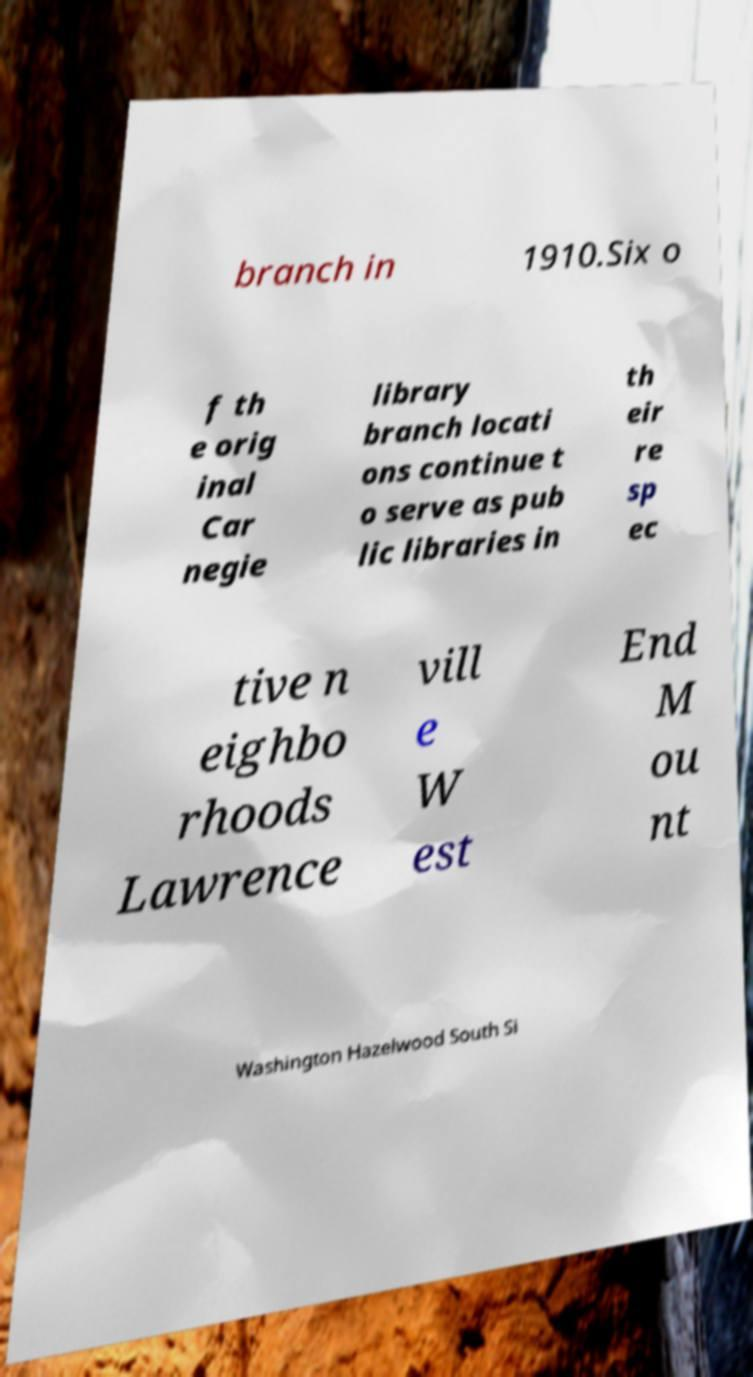I need the written content from this picture converted into text. Can you do that? branch in 1910.Six o f th e orig inal Car negie library branch locati ons continue t o serve as pub lic libraries in th eir re sp ec tive n eighbo rhoods Lawrence vill e W est End M ou nt Washington Hazelwood South Si 